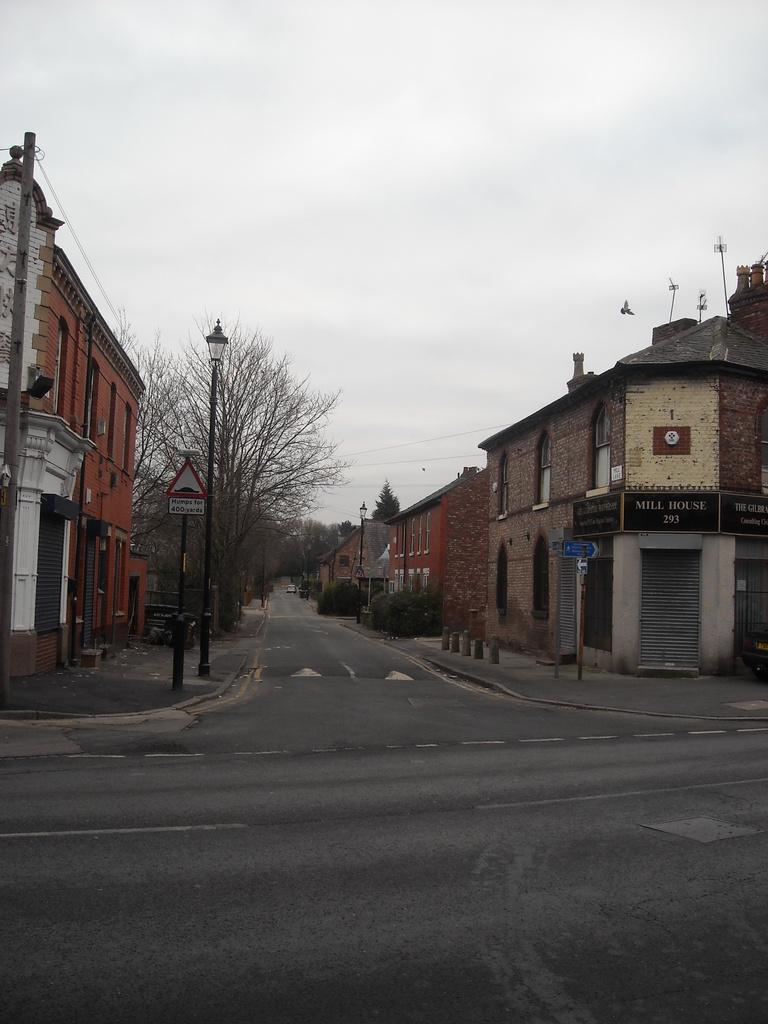What type of infrastructure can be seen in the image? There are roads, poles, and street lights in the image. What type of structures are present in the image? There are buildings in the image. What type of vegetation is present in the image? There are trees in the image. What is visible in the background of the image? The sky is visible in the image. What type of signage is present in the image? There are boards with writing in the image. What type of breakfast is being served on the poles in the image? There is no breakfast present in the image, and the poles are not serving any food. How much attention is the dime receiving in the image? There is no dime present in the image, so it cannot receive any attention. 